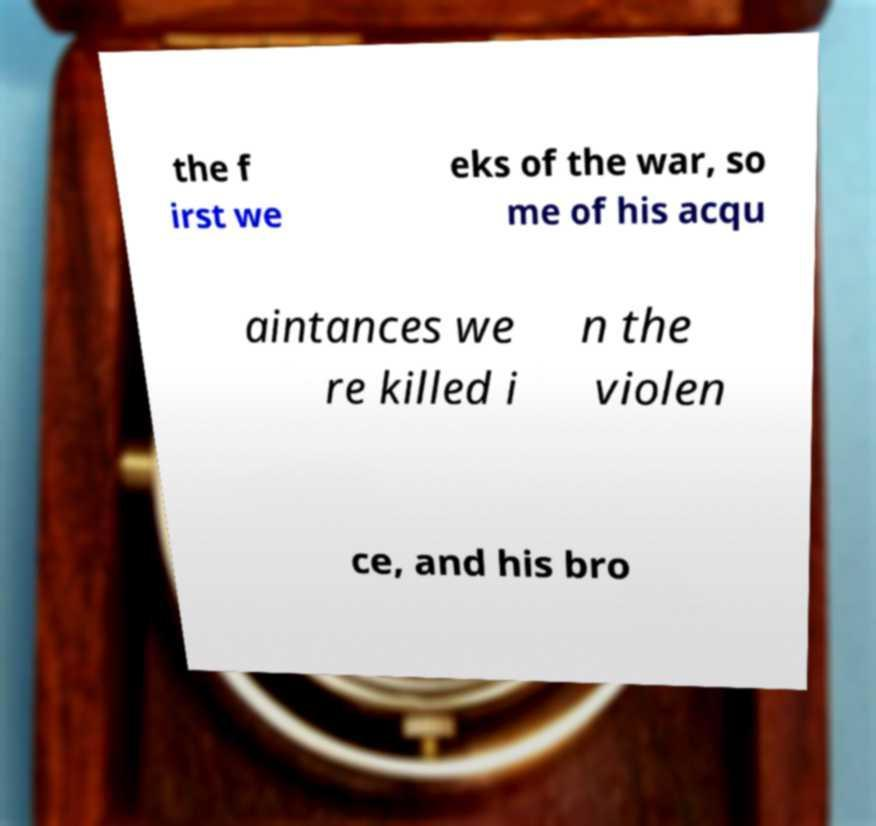Can you accurately transcribe the text from the provided image for me? the f irst we eks of the war, so me of his acqu aintances we re killed i n the violen ce, and his bro 